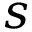Convert formula to latex. <formula><loc_0><loc_0><loc_500><loc_500>s</formula> 